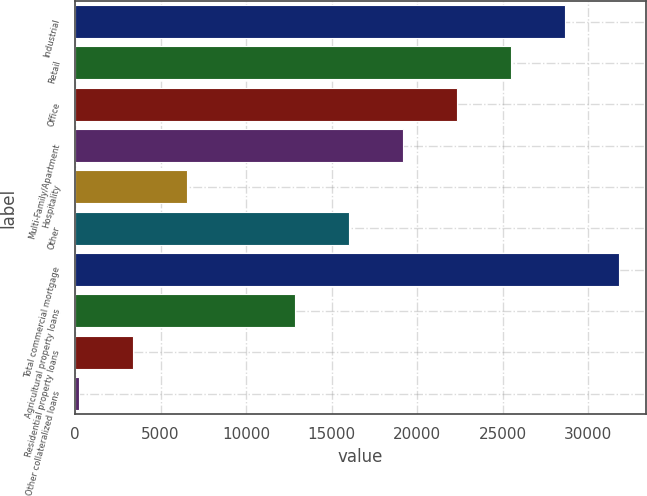Convert chart to OTSL. <chart><loc_0><loc_0><loc_500><loc_500><bar_chart><fcel>Industrial<fcel>Retail<fcel>Office<fcel>Multi-Family/Apartment<fcel>Hospitality<fcel>Other<fcel>Total commercial mortgage<fcel>Agricultural property loans<fcel>Residential property loans<fcel>Other collateralized loans<nl><fcel>28616<fcel>25460<fcel>22304<fcel>19148<fcel>6524<fcel>15992<fcel>31772<fcel>12836<fcel>3368<fcel>212<nl></chart> 